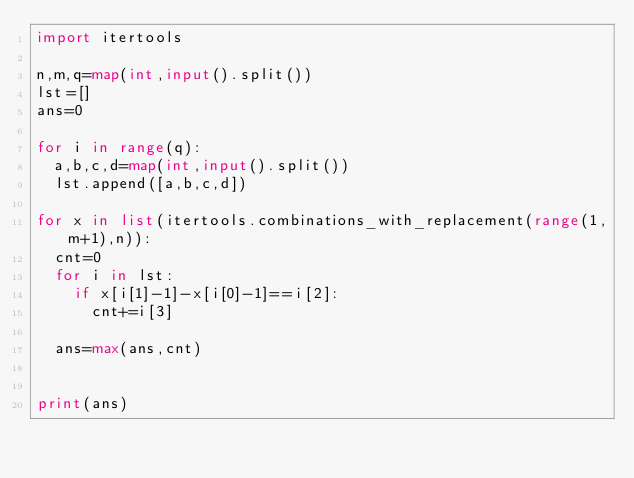Convert code to text. <code><loc_0><loc_0><loc_500><loc_500><_Python_>import itertools

n,m,q=map(int,input().split())
lst=[]
ans=0

for i in range(q):
  a,b,c,d=map(int,input().split())
  lst.append([a,b,c,d])

for x in list(itertools.combinations_with_replacement(range(1,m+1),n)):
  cnt=0
  for i in lst:
    if x[i[1]-1]-x[i[0]-1]==i[2]:
      cnt+=i[3]

  ans=max(ans,cnt)


print(ans)</code> 